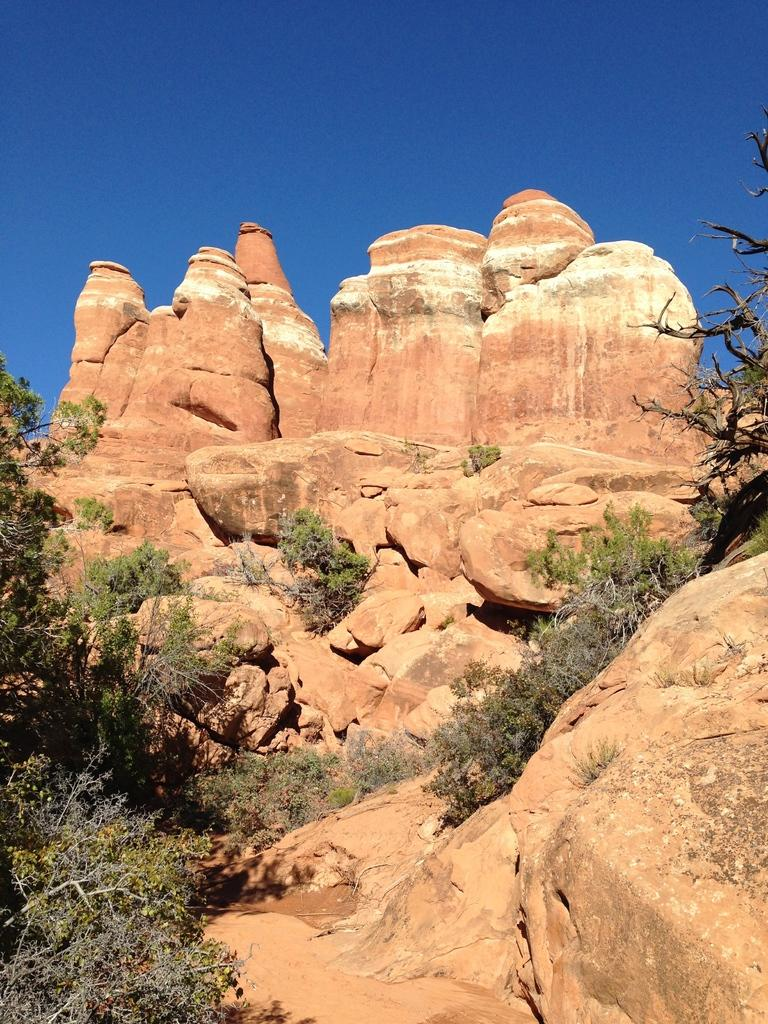What type of landscape is shown in the image? The image depicts a hill. What can be found on the hill? There are rocks and small plants present on the hill. Are there any trees visible on the hill? Yes, trees with branches and leaves are visible on the hill. What type of coil is wrapped around the trees on the hill? There is no coil present in the image; the trees have branches and leaves. What type of juice can be seen dripping from the rocks on the hill? There is no juice present in the image; the rocks are stationary on the hill. 